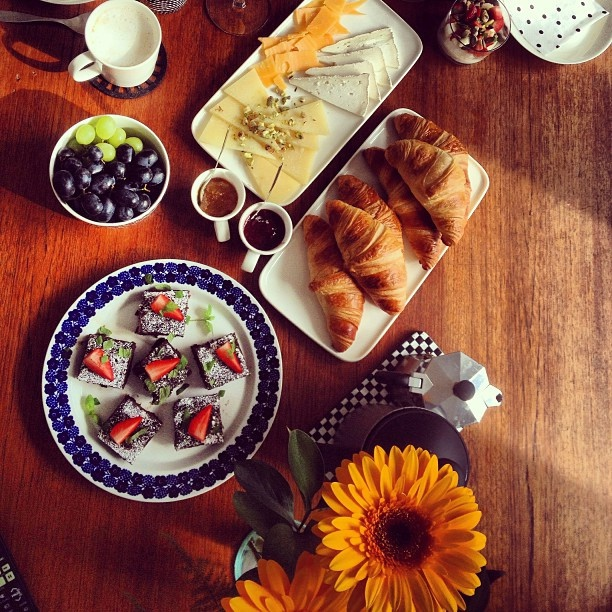Describe the objects in this image and their specific colors. I can see dining table in maroon, black, brown, and tan tones, potted plant in maroon, black, brown, and orange tones, bowl in maroon, black, ivory, gray, and khaki tones, cup in maroon, beige, and tan tones, and bowl in maroon, beige, darkgray, and gray tones in this image. 